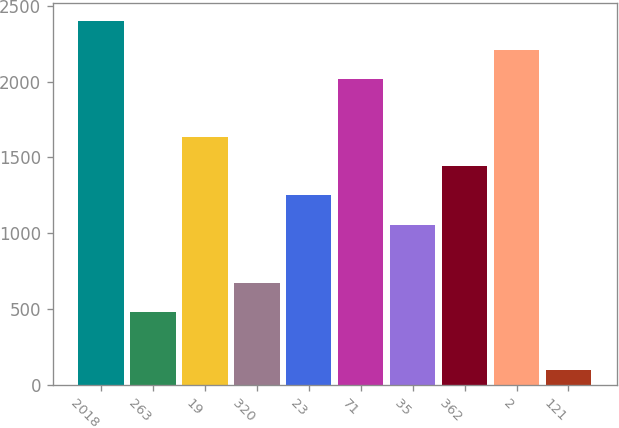<chart> <loc_0><loc_0><loc_500><loc_500><bar_chart><fcel>2018<fcel>263<fcel>19<fcel>320<fcel>23<fcel>71<fcel>35<fcel>362<fcel>2<fcel>121<nl><fcel>2400.8<fcel>481.8<fcel>1633.2<fcel>673.7<fcel>1249.4<fcel>2017<fcel>1057.5<fcel>1441.3<fcel>2208.9<fcel>98<nl></chart> 